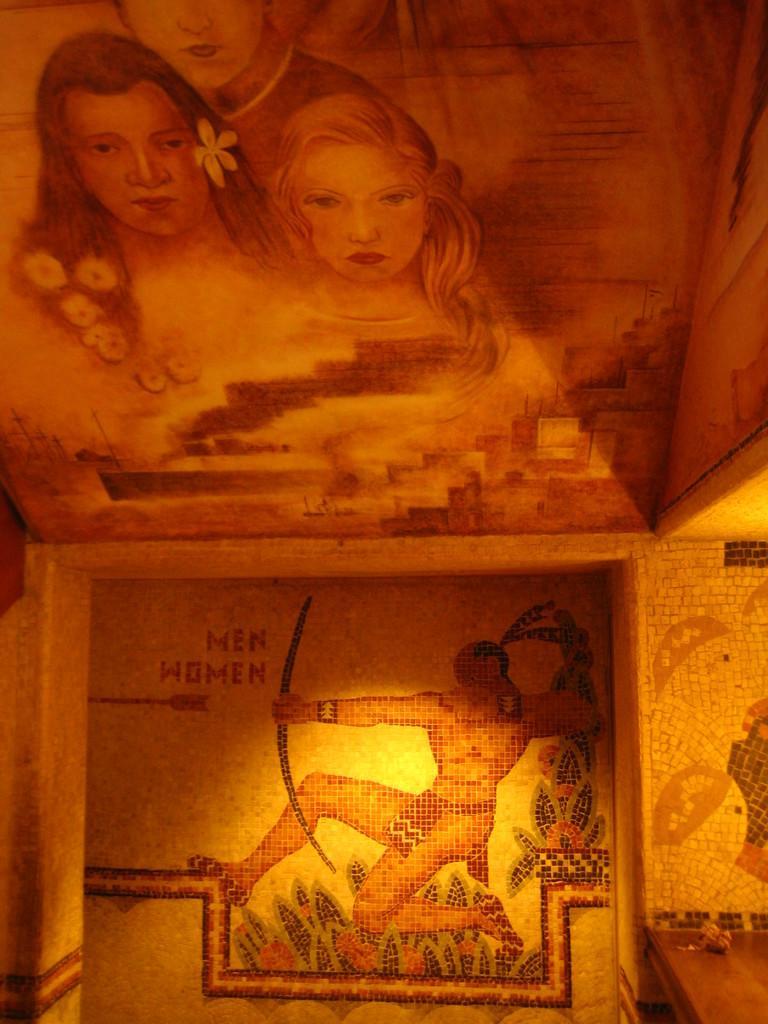Could you give a brief overview of what you see in this image? In this picture we can see an object on a wooden shelf. There is an art visible throughout the image. We can see a few people and a text in this art. 